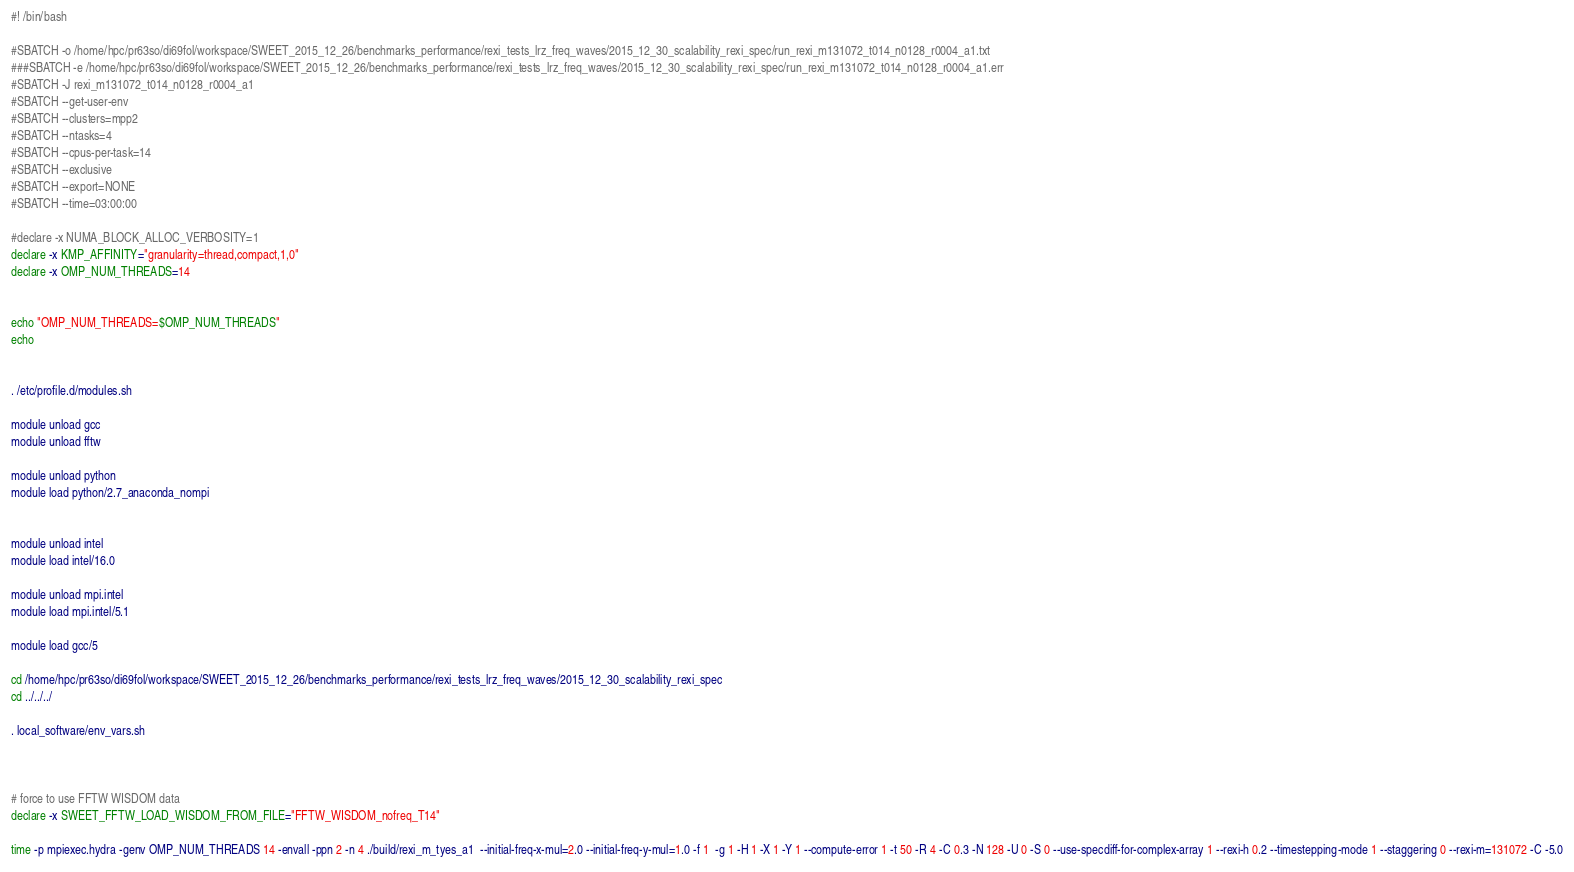Convert code to text. <code><loc_0><loc_0><loc_500><loc_500><_Bash_>#! /bin/bash

#SBATCH -o /home/hpc/pr63so/di69fol/workspace/SWEET_2015_12_26/benchmarks_performance/rexi_tests_lrz_freq_waves/2015_12_30_scalability_rexi_spec/run_rexi_m131072_t014_n0128_r0004_a1.txt
###SBATCH -e /home/hpc/pr63so/di69fol/workspace/SWEET_2015_12_26/benchmarks_performance/rexi_tests_lrz_freq_waves/2015_12_30_scalability_rexi_spec/run_rexi_m131072_t014_n0128_r0004_a1.err
#SBATCH -J rexi_m131072_t014_n0128_r0004_a1
#SBATCH --get-user-env
#SBATCH --clusters=mpp2
#SBATCH --ntasks=4
#SBATCH --cpus-per-task=14
#SBATCH --exclusive
#SBATCH --export=NONE
#SBATCH --time=03:00:00

#declare -x NUMA_BLOCK_ALLOC_VERBOSITY=1
declare -x KMP_AFFINITY="granularity=thread,compact,1,0"
declare -x OMP_NUM_THREADS=14


echo "OMP_NUM_THREADS=$OMP_NUM_THREADS"
echo


. /etc/profile.d/modules.sh

module unload gcc
module unload fftw

module unload python
module load python/2.7_anaconda_nompi


module unload intel
module load intel/16.0

module unload mpi.intel
module load mpi.intel/5.1

module load gcc/5

cd /home/hpc/pr63so/di69fol/workspace/SWEET_2015_12_26/benchmarks_performance/rexi_tests_lrz_freq_waves/2015_12_30_scalability_rexi_spec
cd ../../../

. local_software/env_vars.sh



# force to use FFTW WISDOM data
declare -x SWEET_FFTW_LOAD_WISDOM_FROM_FILE="FFTW_WISDOM_nofreq_T14"

time -p mpiexec.hydra -genv OMP_NUM_THREADS 14 -envall -ppn 2 -n 4 ./build/rexi_m_tyes_a1  --initial-freq-x-mul=2.0 --initial-freq-y-mul=1.0 -f 1  -g 1 -H 1 -X 1 -Y 1 --compute-error 1 -t 50 -R 4 -C 0.3 -N 128 -U 0 -S 0 --use-specdiff-for-complex-array 1 --rexi-h 0.2 --timestepping-mode 1 --staggering 0 --rexi-m=131072 -C -5.0

</code> 